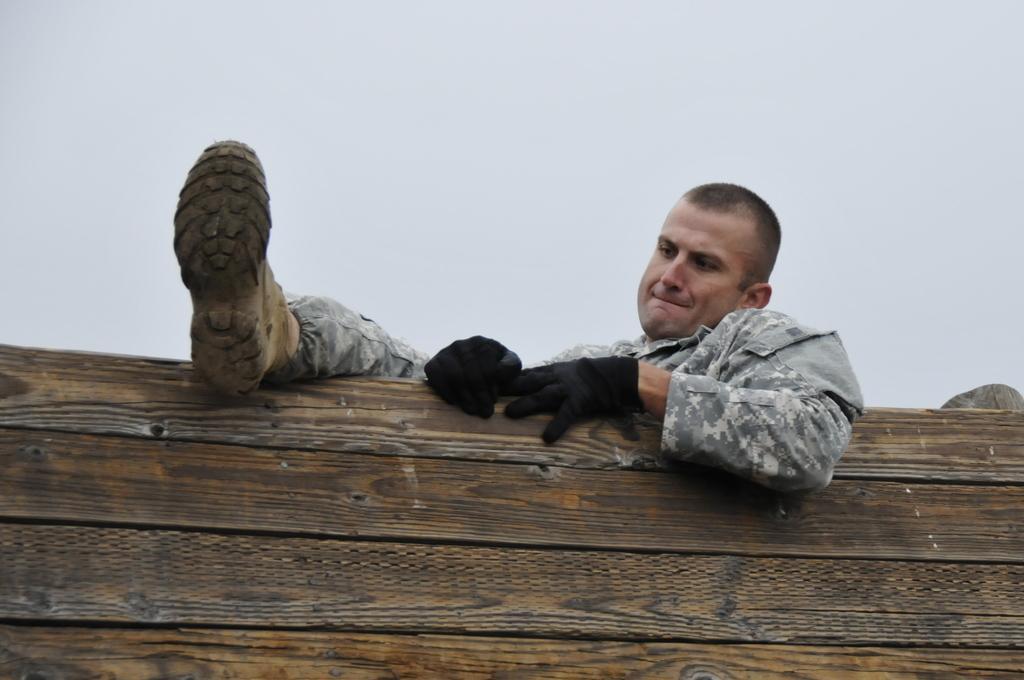Can you describe this image briefly? In this picture we observe an army guy who is wearing gloves and boots is trying to get above the wooden wall. 